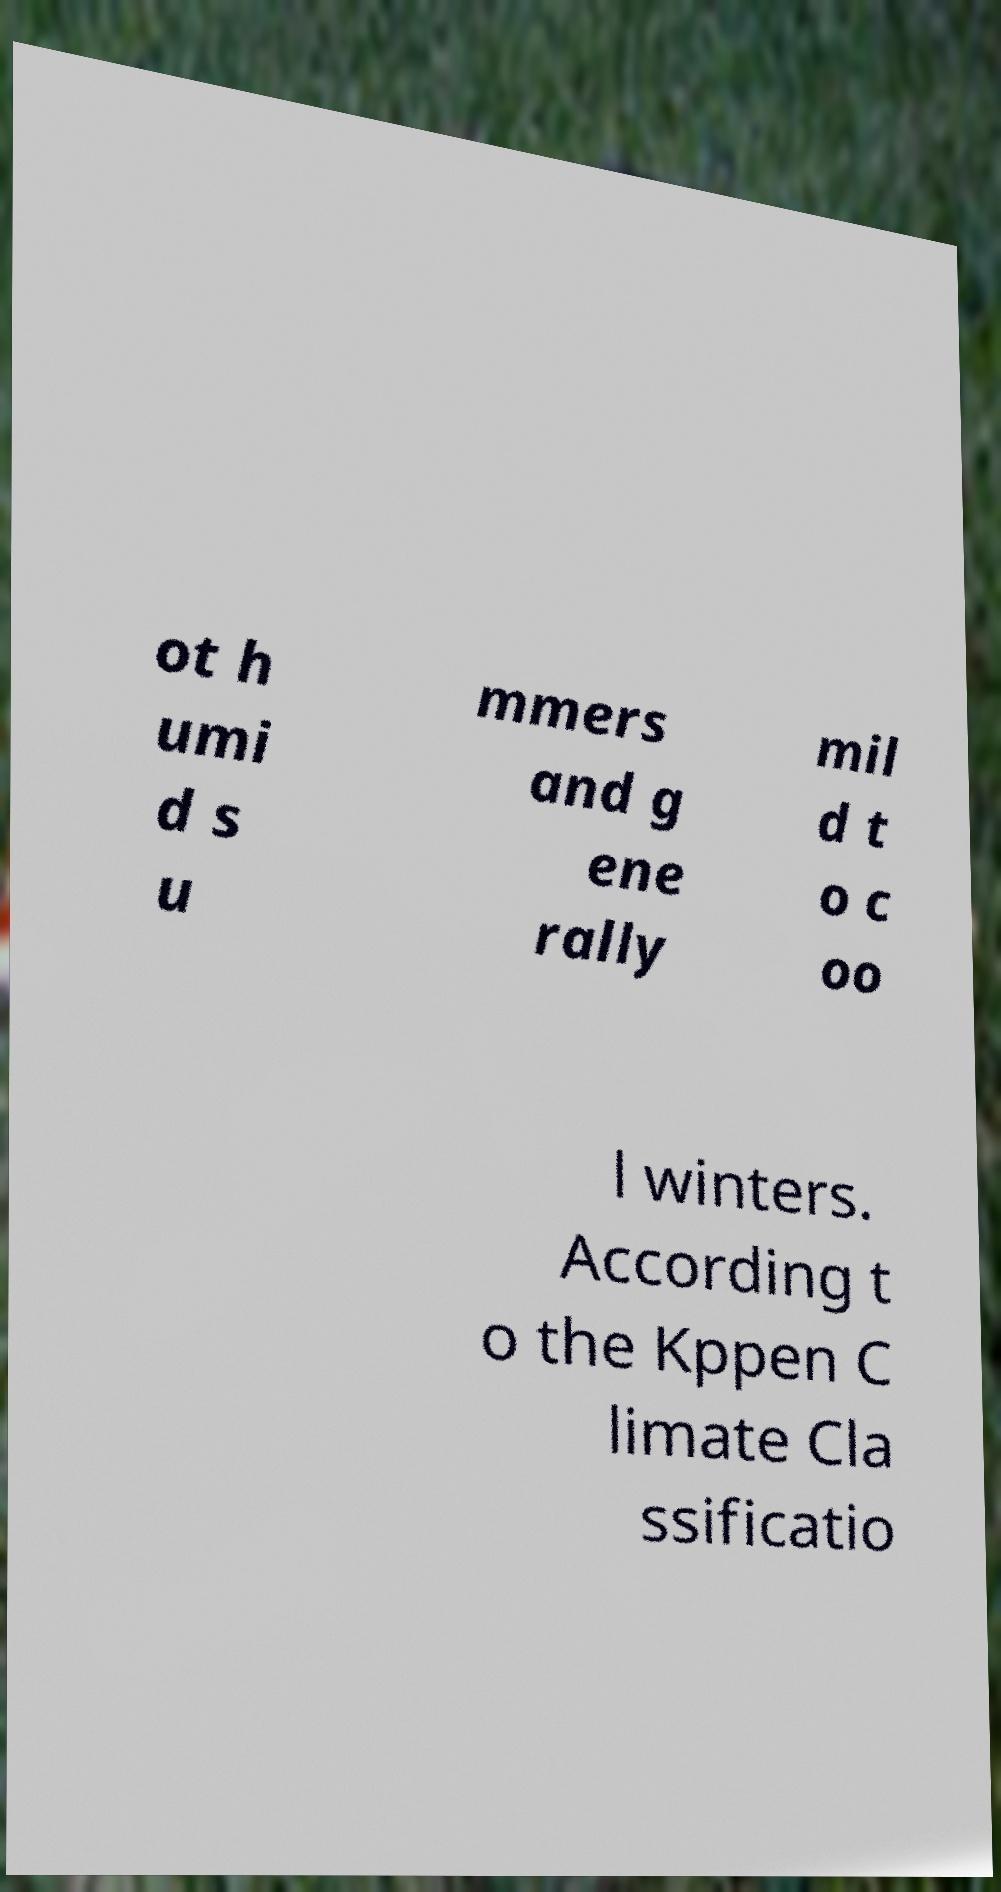There's text embedded in this image that I need extracted. Can you transcribe it verbatim? ot h umi d s u mmers and g ene rally mil d t o c oo l winters. According t o the Kppen C limate Cla ssificatio 